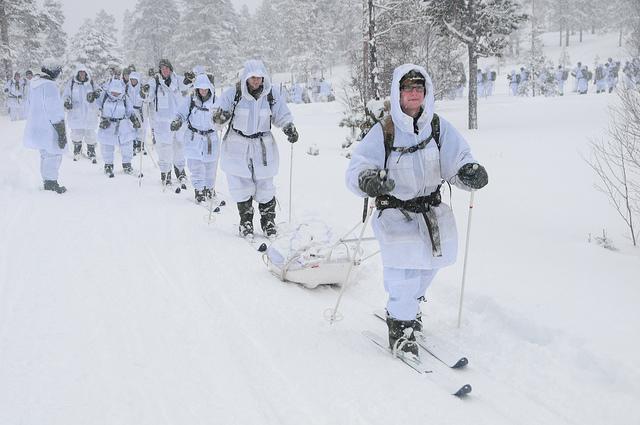What child is wearing black pants?
Keep it brief. None. What are the people doing?
Short answer required. Skiing. Is the person going fast?
Be succinct. No. What devices are at the boys feet?
Answer briefly. Skis. What are these people doing?
Be succinct. Skiing. Is this a modern photo?
Write a very short answer. Yes. Is this a group of military skiers?
Quick response, please. Yes. Is the man standing alone on the left wearing a backpack?
Keep it brief. No. Is this an old photo?
Short answer required. No. 